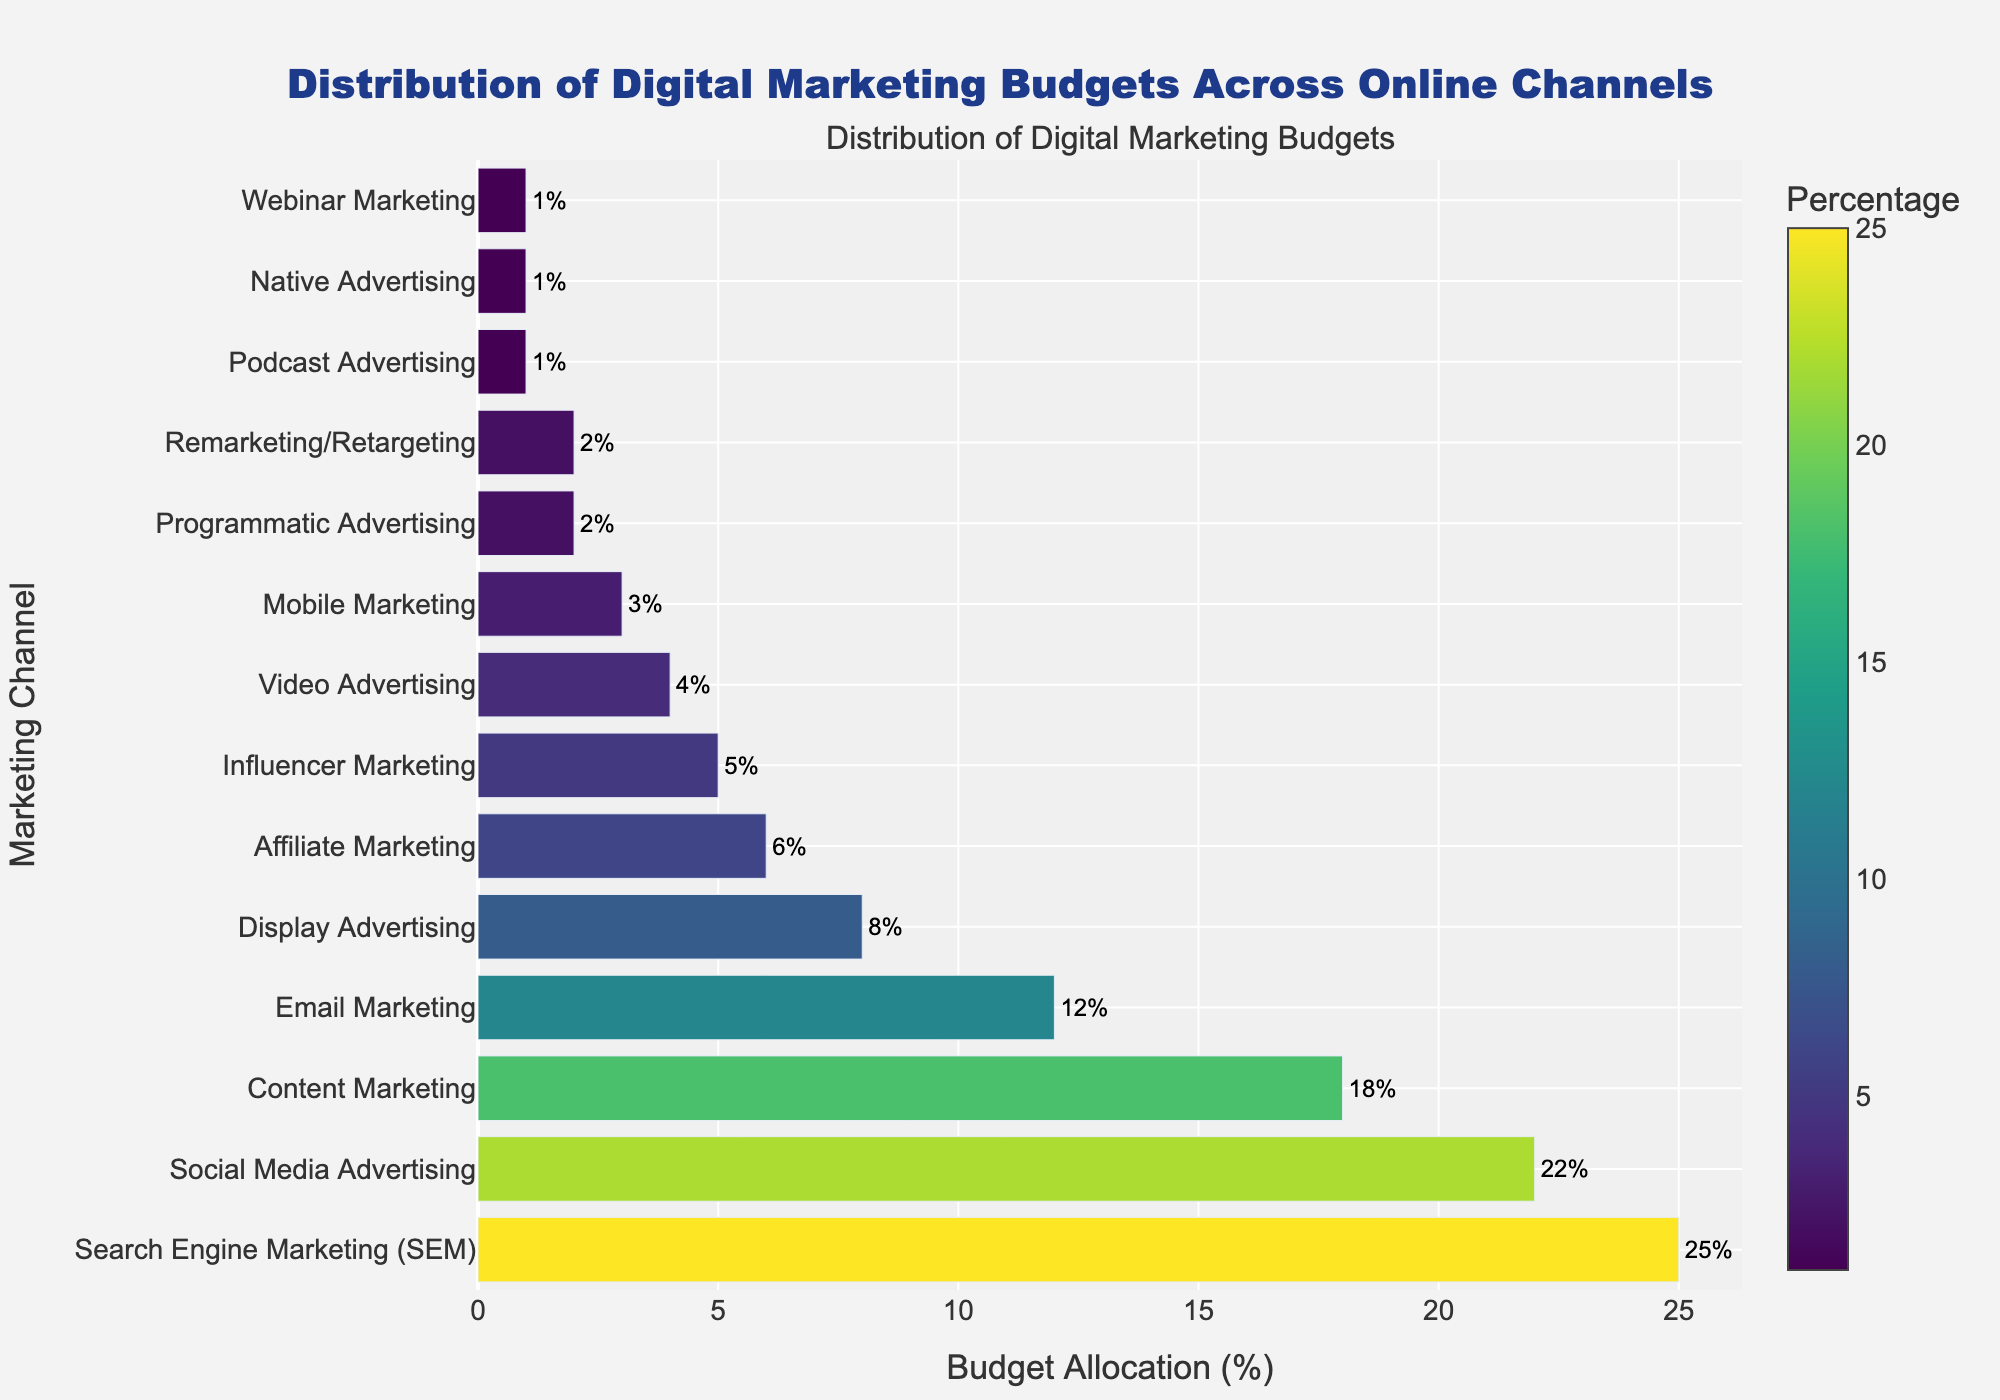what's the total percentage allocated to Search Engine Marketing (SEM) and Social Media Advertising? To find the total percentage allocated to Search Engine Marketing (SEM) and Social Media Advertising, we sum their individual percentages: 25% (SEM) + 22% (Social Media Advertising) = 47%.
Answer: 47% Which channel has a higher budget allocation, Content Marketing or Email Marketing? By comparing their percentages, Content Marketing has 18% while Email Marketing has 12%. Since 18% is greater than 12%, Content Marketing has a higher budget allocation.
Answer: Content Marketing What is the smallest budget allocation and which channel does it belong to? The smallest budget allocation is 1%, and examining the figure, it belongs to Podcast Advertising, Native Advertising, and Webinar Marketing.
Answer: Podcast Advertising, Native Advertising, Webinar Marketing What is the combined budget allocation for channels with less than 5%? Channels with less than 5% are Video Advertising (4%), Mobile Marketing (3%), Programmatic Advertising (2%), Remarketing/Retargeting (2%), Podcast Advertising (1%), Native Advertising (1%), and Webinar Marketing (1%). Adding these together: 4% + 3% + 2% + 2% + 1% + 1% + 1% = 14%.
Answer: 14% What color scheme is used to represent the percentages on the bars? The colors used on the bars are based on the Viridis colorscale, which typically includes shades of blue, green, and yellow.
Answer: Viridis colorscale Which marketing channel is represented by the longest bar and what is its percentage? The longest bar represents Search Engine Marketing (SEM), which has the highest percentage of 25%.
Answer: Search Engine Marketing (SEM) By how much does the budget allocation for Social Media Advertising exceed that for Display Advertising? The budget allocation for Social Media Advertising is 22% and for Display Advertising, it is 8%. To find the difference: 22% - 8% = 14%.
Answer: 14% Which channels fall under a budget allocation of exactly 2%? The channels with exactly 2% budget allocation are Programmatic Advertising and Remarketing/Retargeting.
Answer: Programmatic Advertising, Remarketing/Retargeting How does the color intensity change with the percentage value in the bars? In the Viridis colorscale, as the percentage value increases, the color intensity typically shifts from darker shades (yellow/green) to lighter shades (blue).
Answer: Increases Considering the top three channels, what percentage of the overall budget do they represent together? The top three channels are Search Engine Marketing (SEM = 25%), Social Media Advertising (22%), and Content Marketing (18%). Summing these: 25% + 22% + 18% = 65%.
Answer: 65% 